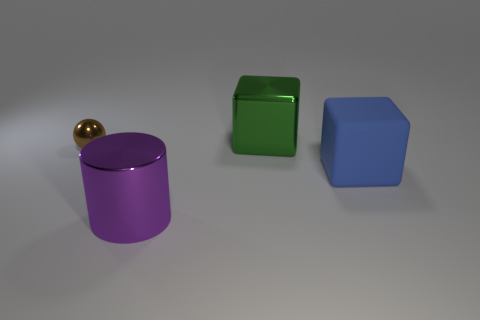There is a large object that is both behind the big purple metallic thing and in front of the green metal block; what is its shape? The object situated between the large purple cylinder and the green block is a blue cube. It has six sides, each side a square of equal size, representing the classic cubic shape. 